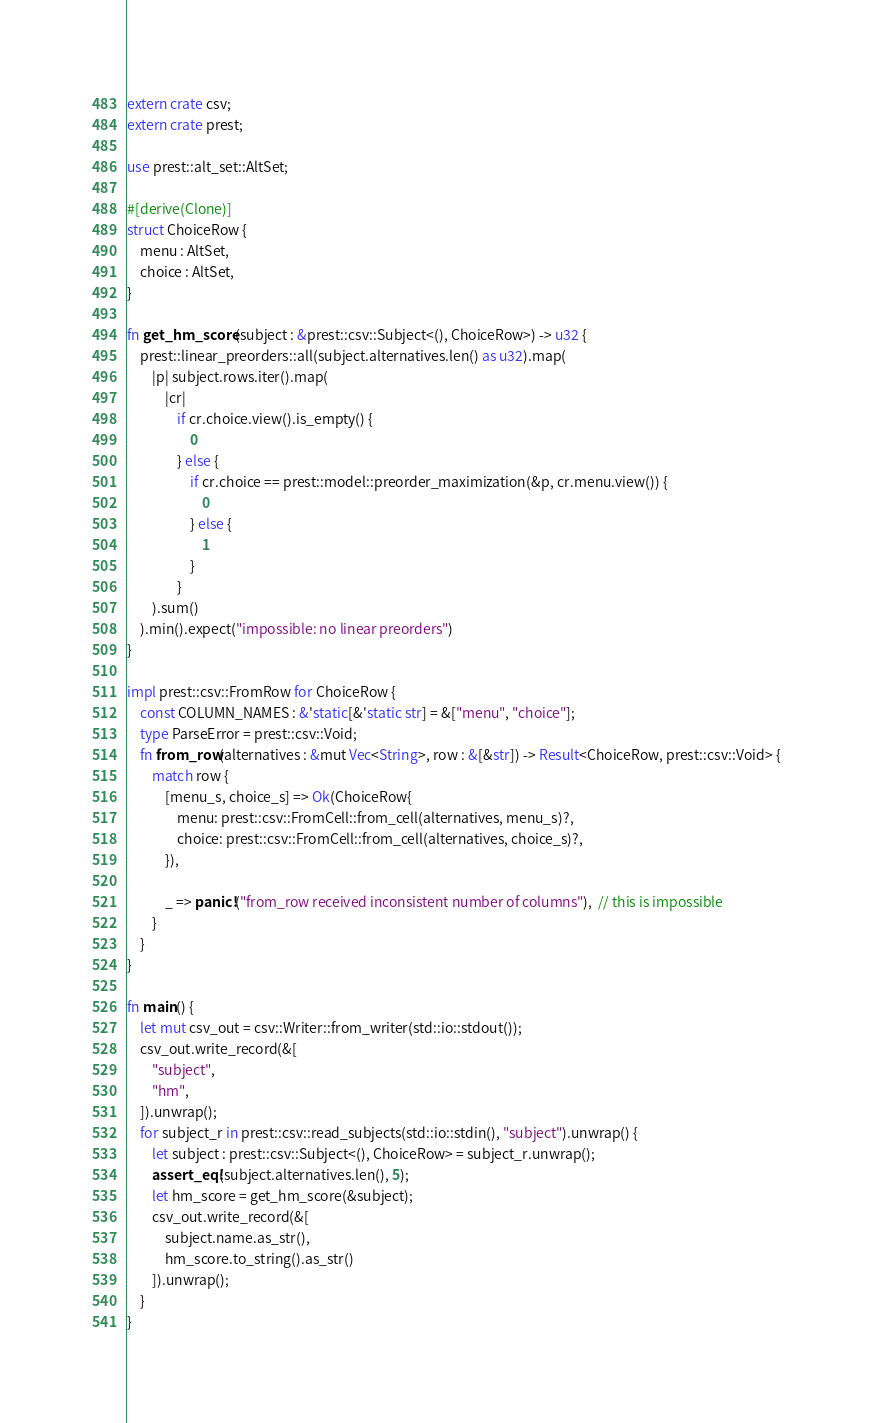Convert code to text. <code><loc_0><loc_0><loc_500><loc_500><_Rust_>extern crate csv;
extern crate prest;

use prest::alt_set::AltSet;

#[derive(Clone)]
struct ChoiceRow {
    menu : AltSet,
    choice : AltSet,
}

fn get_hm_score(subject : &prest::csv::Subject<(), ChoiceRow>) -> u32 {
    prest::linear_preorders::all(subject.alternatives.len() as u32).map(
        |p| subject.rows.iter().map(
            |cr|
                if cr.choice.view().is_empty() {
                    0
                } else {
                    if cr.choice == prest::model::preorder_maximization(&p, cr.menu.view()) {
                        0
                    } else {
                        1
                    }
                }
        ).sum()
    ).min().expect("impossible: no linear preorders")
}

impl prest::csv::FromRow for ChoiceRow {
    const COLUMN_NAMES : &'static[&'static str] = &["menu", "choice"];
    type ParseError = prest::csv::Void;
    fn from_row(alternatives : &mut Vec<String>, row : &[&str]) -> Result<ChoiceRow, prest::csv::Void> {
        match row {
            [menu_s, choice_s] => Ok(ChoiceRow{
                menu: prest::csv::FromCell::from_cell(alternatives, menu_s)?,
                choice: prest::csv::FromCell::from_cell(alternatives, choice_s)?,
            }),

            _ => panic!("from_row received inconsistent number of columns"),  // this is impossible
        }
    }
}

fn main() {
    let mut csv_out = csv::Writer::from_writer(std::io::stdout());
    csv_out.write_record(&[
        "subject",
        "hm",
    ]).unwrap();
    for subject_r in prest::csv::read_subjects(std::io::stdin(), "subject").unwrap() {
        let subject : prest::csv::Subject<(), ChoiceRow> = subject_r.unwrap();
        assert_eq!(subject.alternatives.len(), 5);
        let hm_score = get_hm_score(&subject);
        csv_out.write_record(&[
            subject.name.as_str(),
            hm_score.to_string().as_str()
        ]).unwrap();
    }
}
</code> 